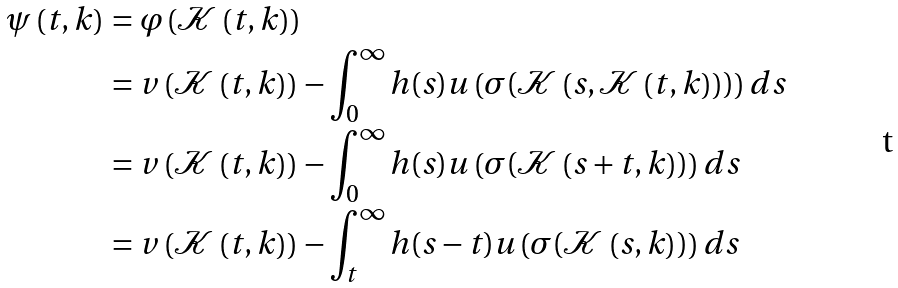Convert formula to latex. <formula><loc_0><loc_0><loc_500><loc_500>\psi \left ( t , k \right ) & = \varphi \left ( \mathcal { K } \left ( t , k \right ) \right ) \\ & = v \left ( \mathcal { K } \left ( t , k \right ) \right ) - \int _ { 0 } ^ { \infty } h ( s ) u \left ( \sigma ( \mathcal { K } \left ( s , \mathcal { K } \left ( t , k \right ) \right ) ) \right ) d s \\ & = v \left ( \mathcal { K } \left ( t , k \right ) \right ) - \int _ { 0 } ^ { \infty } h ( s ) u \left ( \sigma ( \mathcal { K } \left ( s + t , k \right ) ) \right ) d s \\ & = v \left ( \mathcal { K } \left ( t , k \right ) \right ) - \int _ { t } ^ { \infty } h ( s - t ) u \left ( \sigma ( \mathcal { K } \left ( s , k \right ) ) \right ) d s</formula> 